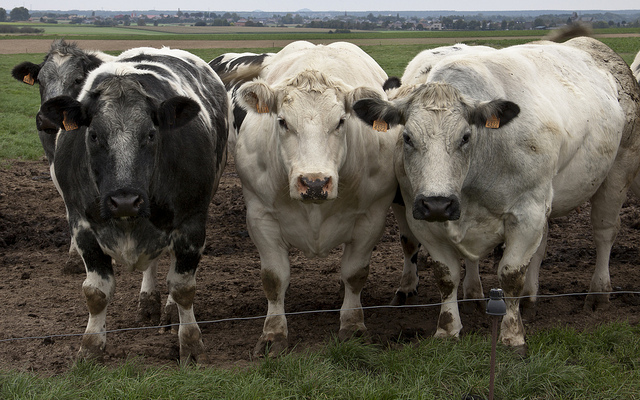Can you discuss the possible breeds of these cows and how that could influence their management? From the image, the cows appear to be of mixed breeds. The cow on the far left exhibits characteristics similar to those of the Holstein Friesian breed, known for its black and white patches and prominence in dairy production. The primarily white cows could be Charolais, a breed known for meat production. Understanding these breeds helps in managing them, as dairy cows require different feeding and milking schedules compared to beef cattle, which are generally raised for their meat. 